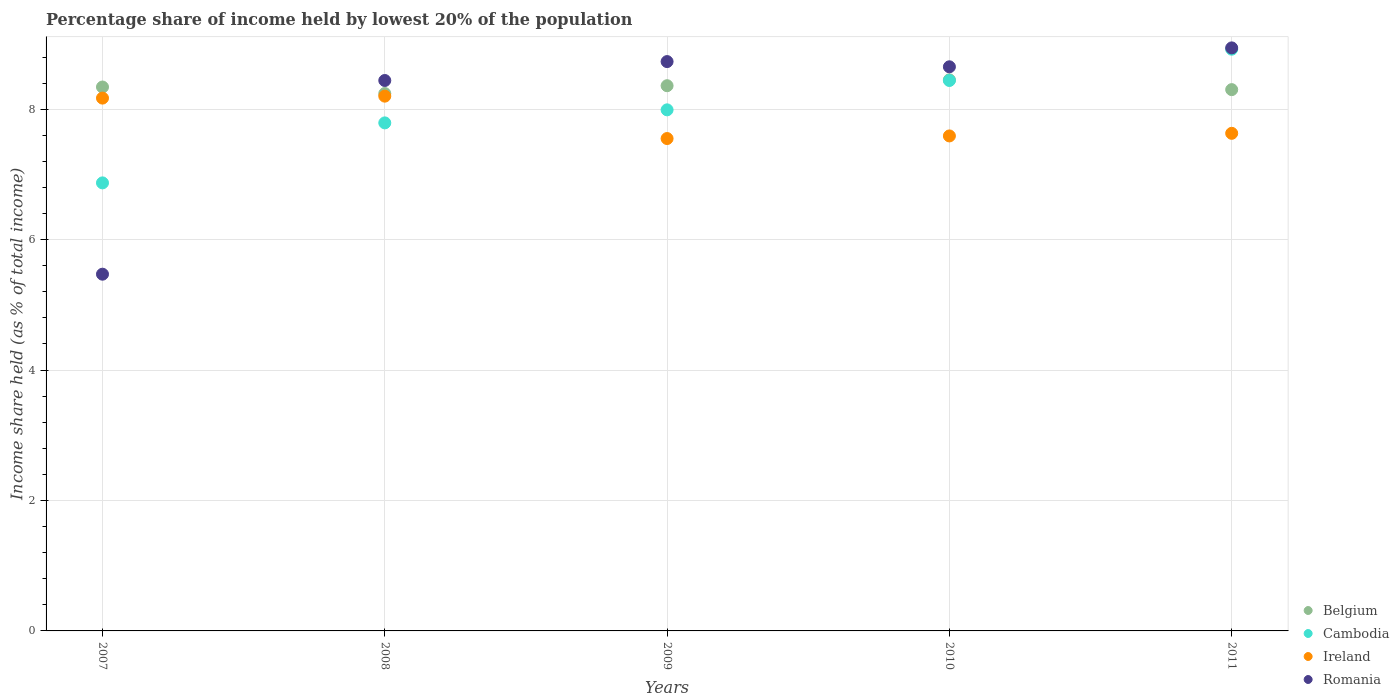How many different coloured dotlines are there?
Offer a very short reply. 4. Is the number of dotlines equal to the number of legend labels?
Give a very brief answer. Yes. What is the percentage share of income held by lowest 20% of the population in Cambodia in 2007?
Provide a succinct answer. 6.87. Across all years, what is the minimum percentage share of income held by lowest 20% of the population in Belgium?
Your response must be concise. 8.24. In which year was the percentage share of income held by lowest 20% of the population in Romania maximum?
Keep it short and to the point. 2011. In which year was the percentage share of income held by lowest 20% of the population in Romania minimum?
Keep it short and to the point. 2007. What is the total percentage share of income held by lowest 20% of the population in Ireland in the graph?
Offer a very short reply. 39.14. What is the difference between the percentage share of income held by lowest 20% of the population in Ireland in 2007 and that in 2010?
Your answer should be very brief. 0.58. What is the difference between the percentage share of income held by lowest 20% of the population in Ireland in 2008 and the percentage share of income held by lowest 20% of the population in Cambodia in 2010?
Provide a succinct answer. -0.24. What is the average percentage share of income held by lowest 20% of the population in Belgium per year?
Ensure brevity in your answer.  8.34. In the year 2011, what is the difference between the percentage share of income held by lowest 20% of the population in Ireland and percentage share of income held by lowest 20% of the population in Romania?
Your response must be concise. -1.31. What is the ratio of the percentage share of income held by lowest 20% of the population in Belgium in 2007 to that in 2009?
Your answer should be compact. 1. Is the difference between the percentage share of income held by lowest 20% of the population in Ireland in 2008 and 2010 greater than the difference between the percentage share of income held by lowest 20% of the population in Romania in 2008 and 2010?
Ensure brevity in your answer.  Yes. What is the difference between the highest and the second highest percentage share of income held by lowest 20% of the population in Belgium?
Keep it short and to the point. 0.09. What is the difference between the highest and the lowest percentage share of income held by lowest 20% of the population in Cambodia?
Your answer should be very brief. 2.05. Is it the case that in every year, the sum of the percentage share of income held by lowest 20% of the population in Belgium and percentage share of income held by lowest 20% of the population in Ireland  is greater than the sum of percentage share of income held by lowest 20% of the population in Romania and percentage share of income held by lowest 20% of the population in Cambodia?
Your response must be concise. No. Is it the case that in every year, the sum of the percentage share of income held by lowest 20% of the population in Romania and percentage share of income held by lowest 20% of the population in Ireland  is greater than the percentage share of income held by lowest 20% of the population in Belgium?
Keep it short and to the point. Yes. Does the percentage share of income held by lowest 20% of the population in Romania monotonically increase over the years?
Provide a short and direct response. No. Is the percentage share of income held by lowest 20% of the population in Belgium strictly greater than the percentage share of income held by lowest 20% of the population in Cambodia over the years?
Your response must be concise. No. Is the percentage share of income held by lowest 20% of the population in Romania strictly less than the percentage share of income held by lowest 20% of the population in Ireland over the years?
Provide a succinct answer. No. How many years are there in the graph?
Provide a short and direct response. 5. Are the values on the major ticks of Y-axis written in scientific E-notation?
Keep it short and to the point. No. Does the graph contain grids?
Offer a very short reply. Yes. Where does the legend appear in the graph?
Your response must be concise. Bottom right. How many legend labels are there?
Provide a succinct answer. 4. What is the title of the graph?
Provide a short and direct response. Percentage share of income held by lowest 20% of the population. What is the label or title of the X-axis?
Provide a succinct answer. Years. What is the label or title of the Y-axis?
Provide a succinct answer. Income share held (as % of total income). What is the Income share held (as % of total income) in Belgium in 2007?
Keep it short and to the point. 8.34. What is the Income share held (as % of total income) in Cambodia in 2007?
Provide a short and direct response. 6.87. What is the Income share held (as % of total income) of Ireland in 2007?
Make the answer very short. 8.17. What is the Income share held (as % of total income) of Romania in 2007?
Provide a short and direct response. 5.47. What is the Income share held (as % of total income) in Belgium in 2008?
Offer a very short reply. 8.24. What is the Income share held (as % of total income) of Cambodia in 2008?
Give a very brief answer. 7.79. What is the Income share held (as % of total income) of Ireland in 2008?
Ensure brevity in your answer.  8.2. What is the Income share held (as % of total income) in Romania in 2008?
Make the answer very short. 8.44. What is the Income share held (as % of total income) in Belgium in 2009?
Provide a short and direct response. 8.36. What is the Income share held (as % of total income) of Cambodia in 2009?
Give a very brief answer. 7.99. What is the Income share held (as % of total income) of Ireland in 2009?
Ensure brevity in your answer.  7.55. What is the Income share held (as % of total income) of Romania in 2009?
Make the answer very short. 8.73. What is the Income share held (as % of total income) in Belgium in 2010?
Offer a terse response. 8.45. What is the Income share held (as % of total income) of Cambodia in 2010?
Provide a short and direct response. 8.44. What is the Income share held (as % of total income) of Ireland in 2010?
Your response must be concise. 7.59. What is the Income share held (as % of total income) of Romania in 2010?
Your answer should be compact. 8.65. What is the Income share held (as % of total income) in Cambodia in 2011?
Give a very brief answer. 8.92. What is the Income share held (as % of total income) in Ireland in 2011?
Keep it short and to the point. 7.63. What is the Income share held (as % of total income) in Romania in 2011?
Ensure brevity in your answer.  8.94. Across all years, what is the maximum Income share held (as % of total income) of Belgium?
Give a very brief answer. 8.45. Across all years, what is the maximum Income share held (as % of total income) in Cambodia?
Ensure brevity in your answer.  8.92. Across all years, what is the maximum Income share held (as % of total income) in Romania?
Give a very brief answer. 8.94. Across all years, what is the minimum Income share held (as % of total income) in Belgium?
Offer a very short reply. 8.24. Across all years, what is the minimum Income share held (as % of total income) in Cambodia?
Give a very brief answer. 6.87. Across all years, what is the minimum Income share held (as % of total income) of Ireland?
Offer a terse response. 7.55. Across all years, what is the minimum Income share held (as % of total income) in Romania?
Provide a short and direct response. 5.47. What is the total Income share held (as % of total income) of Belgium in the graph?
Provide a short and direct response. 41.69. What is the total Income share held (as % of total income) in Cambodia in the graph?
Offer a very short reply. 40.01. What is the total Income share held (as % of total income) in Ireland in the graph?
Your answer should be very brief. 39.14. What is the total Income share held (as % of total income) in Romania in the graph?
Keep it short and to the point. 40.23. What is the difference between the Income share held (as % of total income) in Cambodia in 2007 and that in 2008?
Offer a very short reply. -0.92. What is the difference between the Income share held (as % of total income) of Ireland in 2007 and that in 2008?
Make the answer very short. -0.03. What is the difference between the Income share held (as % of total income) in Romania in 2007 and that in 2008?
Give a very brief answer. -2.97. What is the difference between the Income share held (as % of total income) in Belgium in 2007 and that in 2009?
Your answer should be very brief. -0.02. What is the difference between the Income share held (as % of total income) in Cambodia in 2007 and that in 2009?
Your answer should be very brief. -1.12. What is the difference between the Income share held (as % of total income) in Ireland in 2007 and that in 2009?
Provide a short and direct response. 0.62. What is the difference between the Income share held (as % of total income) of Romania in 2007 and that in 2009?
Offer a very short reply. -3.26. What is the difference between the Income share held (as % of total income) in Belgium in 2007 and that in 2010?
Provide a short and direct response. -0.11. What is the difference between the Income share held (as % of total income) of Cambodia in 2007 and that in 2010?
Provide a short and direct response. -1.57. What is the difference between the Income share held (as % of total income) in Ireland in 2007 and that in 2010?
Offer a very short reply. 0.58. What is the difference between the Income share held (as % of total income) in Romania in 2007 and that in 2010?
Your answer should be compact. -3.18. What is the difference between the Income share held (as % of total income) in Belgium in 2007 and that in 2011?
Keep it short and to the point. 0.04. What is the difference between the Income share held (as % of total income) in Cambodia in 2007 and that in 2011?
Give a very brief answer. -2.05. What is the difference between the Income share held (as % of total income) in Ireland in 2007 and that in 2011?
Your answer should be very brief. 0.54. What is the difference between the Income share held (as % of total income) in Romania in 2007 and that in 2011?
Keep it short and to the point. -3.47. What is the difference between the Income share held (as % of total income) in Belgium in 2008 and that in 2009?
Provide a short and direct response. -0.12. What is the difference between the Income share held (as % of total income) in Ireland in 2008 and that in 2009?
Your response must be concise. 0.65. What is the difference between the Income share held (as % of total income) of Romania in 2008 and that in 2009?
Give a very brief answer. -0.29. What is the difference between the Income share held (as % of total income) in Belgium in 2008 and that in 2010?
Make the answer very short. -0.21. What is the difference between the Income share held (as % of total income) in Cambodia in 2008 and that in 2010?
Your answer should be very brief. -0.65. What is the difference between the Income share held (as % of total income) in Ireland in 2008 and that in 2010?
Keep it short and to the point. 0.61. What is the difference between the Income share held (as % of total income) of Romania in 2008 and that in 2010?
Give a very brief answer. -0.21. What is the difference between the Income share held (as % of total income) in Belgium in 2008 and that in 2011?
Your answer should be very brief. -0.06. What is the difference between the Income share held (as % of total income) in Cambodia in 2008 and that in 2011?
Make the answer very short. -1.13. What is the difference between the Income share held (as % of total income) of Ireland in 2008 and that in 2011?
Give a very brief answer. 0.57. What is the difference between the Income share held (as % of total income) in Romania in 2008 and that in 2011?
Provide a short and direct response. -0.5. What is the difference between the Income share held (as % of total income) in Belgium in 2009 and that in 2010?
Your response must be concise. -0.09. What is the difference between the Income share held (as % of total income) in Cambodia in 2009 and that in 2010?
Make the answer very short. -0.45. What is the difference between the Income share held (as % of total income) of Ireland in 2009 and that in 2010?
Your response must be concise. -0.04. What is the difference between the Income share held (as % of total income) in Romania in 2009 and that in 2010?
Give a very brief answer. 0.08. What is the difference between the Income share held (as % of total income) of Belgium in 2009 and that in 2011?
Ensure brevity in your answer.  0.06. What is the difference between the Income share held (as % of total income) in Cambodia in 2009 and that in 2011?
Give a very brief answer. -0.93. What is the difference between the Income share held (as % of total income) in Ireland in 2009 and that in 2011?
Your response must be concise. -0.08. What is the difference between the Income share held (as % of total income) of Romania in 2009 and that in 2011?
Keep it short and to the point. -0.21. What is the difference between the Income share held (as % of total income) of Cambodia in 2010 and that in 2011?
Ensure brevity in your answer.  -0.48. What is the difference between the Income share held (as % of total income) of Ireland in 2010 and that in 2011?
Ensure brevity in your answer.  -0.04. What is the difference between the Income share held (as % of total income) in Romania in 2010 and that in 2011?
Your response must be concise. -0.29. What is the difference between the Income share held (as % of total income) of Belgium in 2007 and the Income share held (as % of total income) of Cambodia in 2008?
Provide a short and direct response. 0.55. What is the difference between the Income share held (as % of total income) in Belgium in 2007 and the Income share held (as % of total income) in Ireland in 2008?
Offer a very short reply. 0.14. What is the difference between the Income share held (as % of total income) of Belgium in 2007 and the Income share held (as % of total income) of Romania in 2008?
Provide a succinct answer. -0.1. What is the difference between the Income share held (as % of total income) of Cambodia in 2007 and the Income share held (as % of total income) of Ireland in 2008?
Give a very brief answer. -1.33. What is the difference between the Income share held (as % of total income) in Cambodia in 2007 and the Income share held (as % of total income) in Romania in 2008?
Your response must be concise. -1.57. What is the difference between the Income share held (as % of total income) in Ireland in 2007 and the Income share held (as % of total income) in Romania in 2008?
Offer a terse response. -0.27. What is the difference between the Income share held (as % of total income) in Belgium in 2007 and the Income share held (as % of total income) in Cambodia in 2009?
Offer a terse response. 0.35. What is the difference between the Income share held (as % of total income) in Belgium in 2007 and the Income share held (as % of total income) in Ireland in 2009?
Your answer should be very brief. 0.79. What is the difference between the Income share held (as % of total income) of Belgium in 2007 and the Income share held (as % of total income) of Romania in 2009?
Provide a short and direct response. -0.39. What is the difference between the Income share held (as % of total income) of Cambodia in 2007 and the Income share held (as % of total income) of Ireland in 2009?
Ensure brevity in your answer.  -0.68. What is the difference between the Income share held (as % of total income) in Cambodia in 2007 and the Income share held (as % of total income) in Romania in 2009?
Provide a short and direct response. -1.86. What is the difference between the Income share held (as % of total income) in Ireland in 2007 and the Income share held (as % of total income) in Romania in 2009?
Keep it short and to the point. -0.56. What is the difference between the Income share held (as % of total income) of Belgium in 2007 and the Income share held (as % of total income) of Romania in 2010?
Offer a very short reply. -0.31. What is the difference between the Income share held (as % of total income) of Cambodia in 2007 and the Income share held (as % of total income) of Ireland in 2010?
Provide a succinct answer. -0.72. What is the difference between the Income share held (as % of total income) in Cambodia in 2007 and the Income share held (as % of total income) in Romania in 2010?
Ensure brevity in your answer.  -1.78. What is the difference between the Income share held (as % of total income) of Ireland in 2007 and the Income share held (as % of total income) of Romania in 2010?
Give a very brief answer. -0.48. What is the difference between the Income share held (as % of total income) of Belgium in 2007 and the Income share held (as % of total income) of Cambodia in 2011?
Keep it short and to the point. -0.58. What is the difference between the Income share held (as % of total income) in Belgium in 2007 and the Income share held (as % of total income) in Ireland in 2011?
Keep it short and to the point. 0.71. What is the difference between the Income share held (as % of total income) in Cambodia in 2007 and the Income share held (as % of total income) in Ireland in 2011?
Provide a short and direct response. -0.76. What is the difference between the Income share held (as % of total income) in Cambodia in 2007 and the Income share held (as % of total income) in Romania in 2011?
Ensure brevity in your answer.  -2.07. What is the difference between the Income share held (as % of total income) in Ireland in 2007 and the Income share held (as % of total income) in Romania in 2011?
Offer a terse response. -0.77. What is the difference between the Income share held (as % of total income) in Belgium in 2008 and the Income share held (as % of total income) in Cambodia in 2009?
Provide a short and direct response. 0.25. What is the difference between the Income share held (as % of total income) in Belgium in 2008 and the Income share held (as % of total income) in Ireland in 2009?
Your response must be concise. 0.69. What is the difference between the Income share held (as % of total income) of Belgium in 2008 and the Income share held (as % of total income) of Romania in 2009?
Keep it short and to the point. -0.49. What is the difference between the Income share held (as % of total income) of Cambodia in 2008 and the Income share held (as % of total income) of Ireland in 2009?
Give a very brief answer. 0.24. What is the difference between the Income share held (as % of total income) of Cambodia in 2008 and the Income share held (as % of total income) of Romania in 2009?
Provide a succinct answer. -0.94. What is the difference between the Income share held (as % of total income) of Ireland in 2008 and the Income share held (as % of total income) of Romania in 2009?
Offer a very short reply. -0.53. What is the difference between the Income share held (as % of total income) of Belgium in 2008 and the Income share held (as % of total income) of Ireland in 2010?
Offer a terse response. 0.65. What is the difference between the Income share held (as % of total income) of Belgium in 2008 and the Income share held (as % of total income) of Romania in 2010?
Offer a terse response. -0.41. What is the difference between the Income share held (as % of total income) in Cambodia in 2008 and the Income share held (as % of total income) in Romania in 2010?
Make the answer very short. -0.86. What is the difference between the Income share held (as % of total income) of Ireland in 2008 and the Income share held (as % of total income) of Romania in 2010?
Provide a short and direct response. -0.45. What is the difference between the Income share held (as % of total income) in Belgium in 2008 and the Income share held (as % of total income) in Cambodia in 2011?
Your answer should be compact. -0.68. What is the difference between the Income share held (as % of total income) of Belgium in 2008 and the Income share held (as % of total income) of Ireland in 2011?
Your answer should be compact. 0.61. What is the difference between the Income share held (as % of total income) in Cambodia in 2008 and the Income share held (as % of total income) in Ireland in 2011?
Your response must be concise. 0.16. What is the difference between the Income share held (as % of total income) of Cambodia in 2008 and the Income share held (as % of total income) of Romania in 2011?
Provide a short and direct response. -1.15. What is the difference between the Income share held (as % of total income) of Ireland in 2008 and the Income share held (as % of total income) of Romania in 2011?
Offer a terse response. -0.74. What is the difference between the Income share held (as % of total income) in Belgium in 2009 and the Income share held (as % of total income) in Cambodia in 2010?
Your response must be concise. -0.08. What is the difference between the Income share held (as % of total income) in Belgium in 2009 and the Income share held (as % of total income) in Ireland in 2010?
Offer a terse response. 0.77. What is the difference between the Income share held (as % of total income) in Belgium in 2009 and the Income share held (as % of total income) in Romania in 2010?
Offer a very short reply. -0.29. What is the difference between the Income share held (as % of total income) in Cambodia in 2009 and the Income share held (as % of total income) in Ireland in 2010?
Your answer should be compact. 0.4. What is the difference between the Income share held (as % of total income) in Cambodia in 2009 and the Income share held (as % of total income) in Romania in 2010?
Your response must be concise. -0.66. What is the difference between the Income share held (as % of total income) in Ireland in 2009 and the Income share held (as % of total income) in Romania in 2010?
Keep it short and to the point. -1.1. What is the difference between the Income share held (as % of total income) in Belgium in 2009 and the Income share held (as % of total income) in Cambodia in 2011?
Offer a terse response. -0.56. What is the difference between the Income share held (as % of total income) in Belgium in 2009 and the Income share held (as % of total income) in Ireland in 2011?
Make the answer very short. 0.73. What is the difference between the Income share held (as % of total income) in Belgium in 2009 and the Income share held (as % of total income) in Romania in 2011?
Ensure brevity in your answer.  -0.58. What is the difference between the Income share held (as % of total income) in Cambodia in 2009 and the Income share held (as % of total income) in Ireland in 2011?
Ensure brevity in your answer.  0.36. What is the difference between the Income share held (as % of total income) of Cambodia in 2009 and the Income share held (as % of total income) of Romania in 2011?
Make the answer very short. -0.95. What is the difference between the Income share held (as % of total income) of Ireland in 2009 and the Income share held (as % of total income) of Romania in 2011?
Provide a short and direct response. -1.39. What is the difference between the Income share held (as % of total income) of Belgium in 2010 and the Income share held (as % of total income) of Cambodia in 2011?
Offer a very short reply. -0.47. What is the difference between the Income share held (as % of total income) in Belgium in 2010 and the Income share held (as % of total income) in Ireland in 2011?
Make the answer very short. 0.82. What is the difference between the Income share held (as % of total income) of Belgium in 2010 and the Income share held (as % of total income) of Romania in 2011?
Ensure brevity in your answer.  -0.49. What is the difference between the Income share held (as % of total income) in Cambodia in 2010 and the Income share held (as % of total income) in Ireland in 2011?
Provide a succinct answer. 0.81. What is the difference between the Income share held (as % of total income) of Ireland in 2010 and the Income share held (as % of total income) of Romania in 2011?
Offer a terse response. -1.35. What is the average Income share held (as % of total income) in Belgium per year?
Offer a very short reply. 8.34. What is the average Income share held (as % of total income) of Cambodia per year?
Offer a terse response. 8. What is the average Income share held (as % of total income) in Ireland per year?
Your response must be concise. 7.83. What is the average Income share held (as % of total income) in Romania per year?
Ensure brevity in your answer.  8.05. In the year 2007, what is the difference between the Income share held (as % of total income) in Belgium and Income share held (as % of total income) in Cambodia?
Provide a short and direct response. 1.47. In the year 2007, what is the difference between the Income share held (as % of total income) in Belgium and Income share held (as % of total income) in Ireland?
Give a very brief answer. 0.17. In the year 2007, what is the difference between the Income share held (as % of total income) in Belgium and Income share held (as % of total income) in Romania?
Your answer should be compact. 2.87. In the year 2007, what is the difference between the Income share held (as % of total income) in Cambodia and Income share held (as % of total income) in Romania?
Make the answer very short. 1.4. In the year 2007, what is the difference between the Income share held (as % of total income) of Ireland and Income share held (as % of total income) of Romania?
Offer a very short reply. 2.7. In the year 2008, what is the difference between the Income share held (as % of total income) of Belgium and Income share held (as % of total income) of Cambodia?
Keep it short and to the point. 0.45. In the year 2008, what is the difference between the Income share held (as % of total income) of Belgium and Income share held (as % of total income) of Ireland?
Keep it short and to the point. 0.04. In the year 2008, what is the difference between the Income share held (as % of total income) of Cambodia and Income share held (as % of total income) of Ireland?
Make the answer very short. -0.41. In the year 2008, what is the difference between the Income share held (as % of total income) in Cambodia and Income share held (as % of total income) in Romania?
Provide a succinct answer. -0.65. In the year 2008, what is the difference between the Income share held (as % of total income) of Ireland and Income share held (as % of total income) of Romania?
Your answer should be very brief. -0.24. In the year 2009, what is the difference between the Income share held (as % of total income) in Belgium and Income share held (as % of total income) in Cambodia?
Make the answer very short. 0.37. In the year 2009, what is the difference between the Income share held (as % of total income) in Belgium and Income share held (as % of total income) in Ireland?
Your answer should be compact. 0.81. In the year 2009, what is the difference between the Income share held (as % of total income) of Belgium and Income share held (as % of total income) of Romania?
Your answer should be very brief. -0.37. In the year 2009, what is the difference between the Income share held (as % of total income) in Cambodia and Income share held (as % of total income) in Ireland?
Your response must be concise. 0.44. In the year 2009, what is the difference between the Income share held (as % of total income) in Cambodia and Income share held (as % of total income) in Romania?
Provide a succinct answer. -0.74. In the year 2009, what is the difference between the Income share held (as % of total income) of Ireland and Income share held (as % of total income) of Romania?
Your answer should be very brief. -1.18. In the year 2010, what is the difference between the Income share held (as % of total income) of Belgium and Income share held (as % of total income) of Cambodia?
Make the answer very short. 0.01. In the year 2010, what is the difference between the Income share held (as % of total income) of Belgium and Income share held (as % of total income) of Ireland?
Keep it short and to the point. 0.86. In the year 2010, what is the difference between the Income share held (as % of total income) of Cambodia and Income share held (as % of total income) of Ireland?
Ensure brevity in your answer.  0.85. In the year 2010, what is the difference between the Income share held (as % of total income) of Cambodia and Income share held (as % of total income) of Romania?
Your answer should be compact. -0.21. In the year 2010, what is the difference between the Income share held (as % of total income) of Ireland and Income share held (as % of total income) of Romania?
Your response must be concise. -1.06. In the year 2011, what is the difference between the Income share held (as % of total income) in Belgium and Income share held (as % of total income) in Cambodia?
Offer a very short reply. -0.62. In the year 2011, what is the difference between the Income share held (as % of total income) in Belgium and Income share held (as % of total income) in Ireland?
Your answer should be very brief. 0.67. In the year 2011, what is the difference between the Income share held (as % of total income) in Belgium and Income share held (as % of total income) in Romania?
Your response must be concise. -0.64. In the year 2011, what is the difference between the Income share held (as % of total income) of Cambodia and Income share held (as % of total income) of Ireland?
Your answer should be very brief. 1.29. In the year 2011, what is the difference between the Income share held (as % of total income) in Cambodia and Income share held (as % of total income) in Romania?
Provide a succinct answer. -0.02. In the year 2011, what is the difference between the Income share held (as % of total income) of Ireland and Income share held (as % of total income) of Romania?
Provide a short and direct response. -1.31. What is the ratio of the Income share held (as % of total income) of Belgium in 2007 to that in 2008?
Provide a succinct answer. 1.01. What is the ratio of the Income share held (as % of total income) of Cambodia in 2007 to that in 2008?
Your answer should be very brief. 0.88. What is the ratio of the Income share held (as % of total income) of Ireland in 2007 to that in 2008?
Make the answer very short. 1. What is the ratio of the Income share held (as % of total income) of Romania in 2007 to that in 2008?
Keep it short and to the point. 0.65. What is the ratio of the Income share held (as % of total income) in Belgium in 2007 to that in 2009?
Ensure brevity in your answer.  1. What is the ratio of the Income share held (as % of total income) of Cambodia in 2007 to that in 2009?
Provide a succinct answer. 0.86. What is the ratio of the Income share held (as % of total income) in Ireland in 2007 to that in 2009?
Ensure brevity in your answer.  1.08. What is the ratio of the Income share held (as % of total income) of Romania in 2007 to that in 2009?
Your answer should be compact. 0.63. What is the ratio of the Income share held (as % of total income) of Cambodia in 2007 to that in 2010?
Give a very brief answer. 0.81. What is the ratio of the Income share held (as % of total income) of Ireland in 2007 to that in 2010?
Your answer should be compact. 1.08. What is the ratio of the Income share held (as % of total income) of Romania in 2007 to that in 2010?
Your response must be concise. 0.63. What is the ratio of the Income share held (as % of total income) of Belgium in 2007 to that in 2011?
Your answer should be compact. 1. What is the ratio of the Income share held (as % of total income) of Cambodia in 2007 to that in 2011?
Your answer should be very brief. 0.77. What is the ratio of the Income share held (as % of total income) in Ireland in 2007 to that in 2011?
Make the answer very short. 1.07. What is the ratio of the Income share held (as % of total income) in Romania in 2007 to that in 2011?
Your answer should be very brief. 0.61. What is the ratio of the Income share held (as % of total income) in Belgium in 2008 to that in 2009?
Your answer should be compact. 0.99. What is the ratio of the Income share held (as % of total income) of Ireland in 2008 to that in 2009?
Your answer should be very brief. 1.09. What is the ratio of the Income share held (as % of total income) in Romania in 2008 to that in 2009?
Your answer should be compact. 0.97. What is the ratio of the Income share held (as % of total income) of Belgium in 2008 to that in 2010?
Offer a very short reply. 0.98. What is the ratio of the Income share held (as % of total income) in Cambodia in 2008 to that in 2010?
Your answer should be very brief. 0.92. What is the ratio of the Income share held (as % of total income) in Ireland in 2008 to that in 2010?
Offer a very short reply. 1.08. What is the ratio of the Income share held (as % of total income) of Romania in 2008 to that in 2010?
Give a very brief answer. 0.98. What is the ratio of the Income share held (as % of total income) of Belgium in 2008 to that in 2011?
Your response must be concise. 0.99. What is the ratio of the Income share held (as % of total income) of Cambodia in 2008 to that in 2011?
Give a very brief answer. 0.87. What is the ratio of the Income share held (as % of total income) in Ireland in 2008 to that in 2011?
Provide a short and direct response. 1.07. What is the ratio of the Income share held (as % of total income) of Romania in 2008 to that in 2011?
Provide a succinct answer. 0.94. What is the ratio of the Income share held (as % of total income) in Belgium in 2009 to that in 2010?
Offer a very short reply. 0.99. What is the ratio of the Income share held (as % of total income) in Cambodia in 2009 to that in 2010?
Ensure brevity in your answer.  0.95. What is the ratio of the Income share held (as % of total income) of Romania in 2009 to that in 2010?
Offer a very short reply. 1.01. What is the ratio of the Income share held (as % of total income) in Belgium in 2009 to that in 2011?
Offer a terse response. 1.01. What is the ratio of the Income share held (as % of total income) in Cambodia in 2009 to that in 2011?
Keep it short and to the point. 0.9. What is the ratio of the Income share held (as % of total income) in Ireland in 2009 to that in 2011?
Provide a succinct answer. 0.99. What is the ratio of the Income share held (as % of total income) of Romania in 2009 to that in 2011?
Offer a terse response. 0.98. What is the ratio of the Income share held (as % of total income) of Belgium in 2010 to that in 2011?
Offer a terse response. 1.02. What is the ratio of the Income share held (as % of total income) of Cambodia in 2010 to that in 2011?
Offer a very short reply. 0.95. What is the ratio of the Income share held (as % of total income) in Ireland in 2010 to that in 2011?
Your answer should be compact. 0.99. What is the ratio of the Income share held (as % of total income) of Romania in 2010 to that in 2011?
Make the answer very short. 0.97. What is the difference between the highest and the second highest Income share held (as % of total income) of Belgium?
Your response must be concise. 0.09. What is the difference between the highest and the second highest Income share held (as % of total income) of Cambodia?
Your answer should be compact. 0.48. What is the difference between the highest and the second highest Income share held (as % of total income) in Romania?
Ensure brevity in your answer.  0.21. What is the difference between the highest and the lowest Income share held (as % of total income) in Belgium?
Provide a short and direct response. 0.21. What is the difference between the highest and the lowest Income share held (as % of total income) in Cambodia?
Provide a short and direct response. 2.05. What is the difference between the highest and the lowest Income share held (as % of total income) in Ireland?
Provide a succinct answer. 0.65. What is the difference between the highest and the lowest Income share held (as % of total income) of Romania?
Make the answer very short. 3.47. 